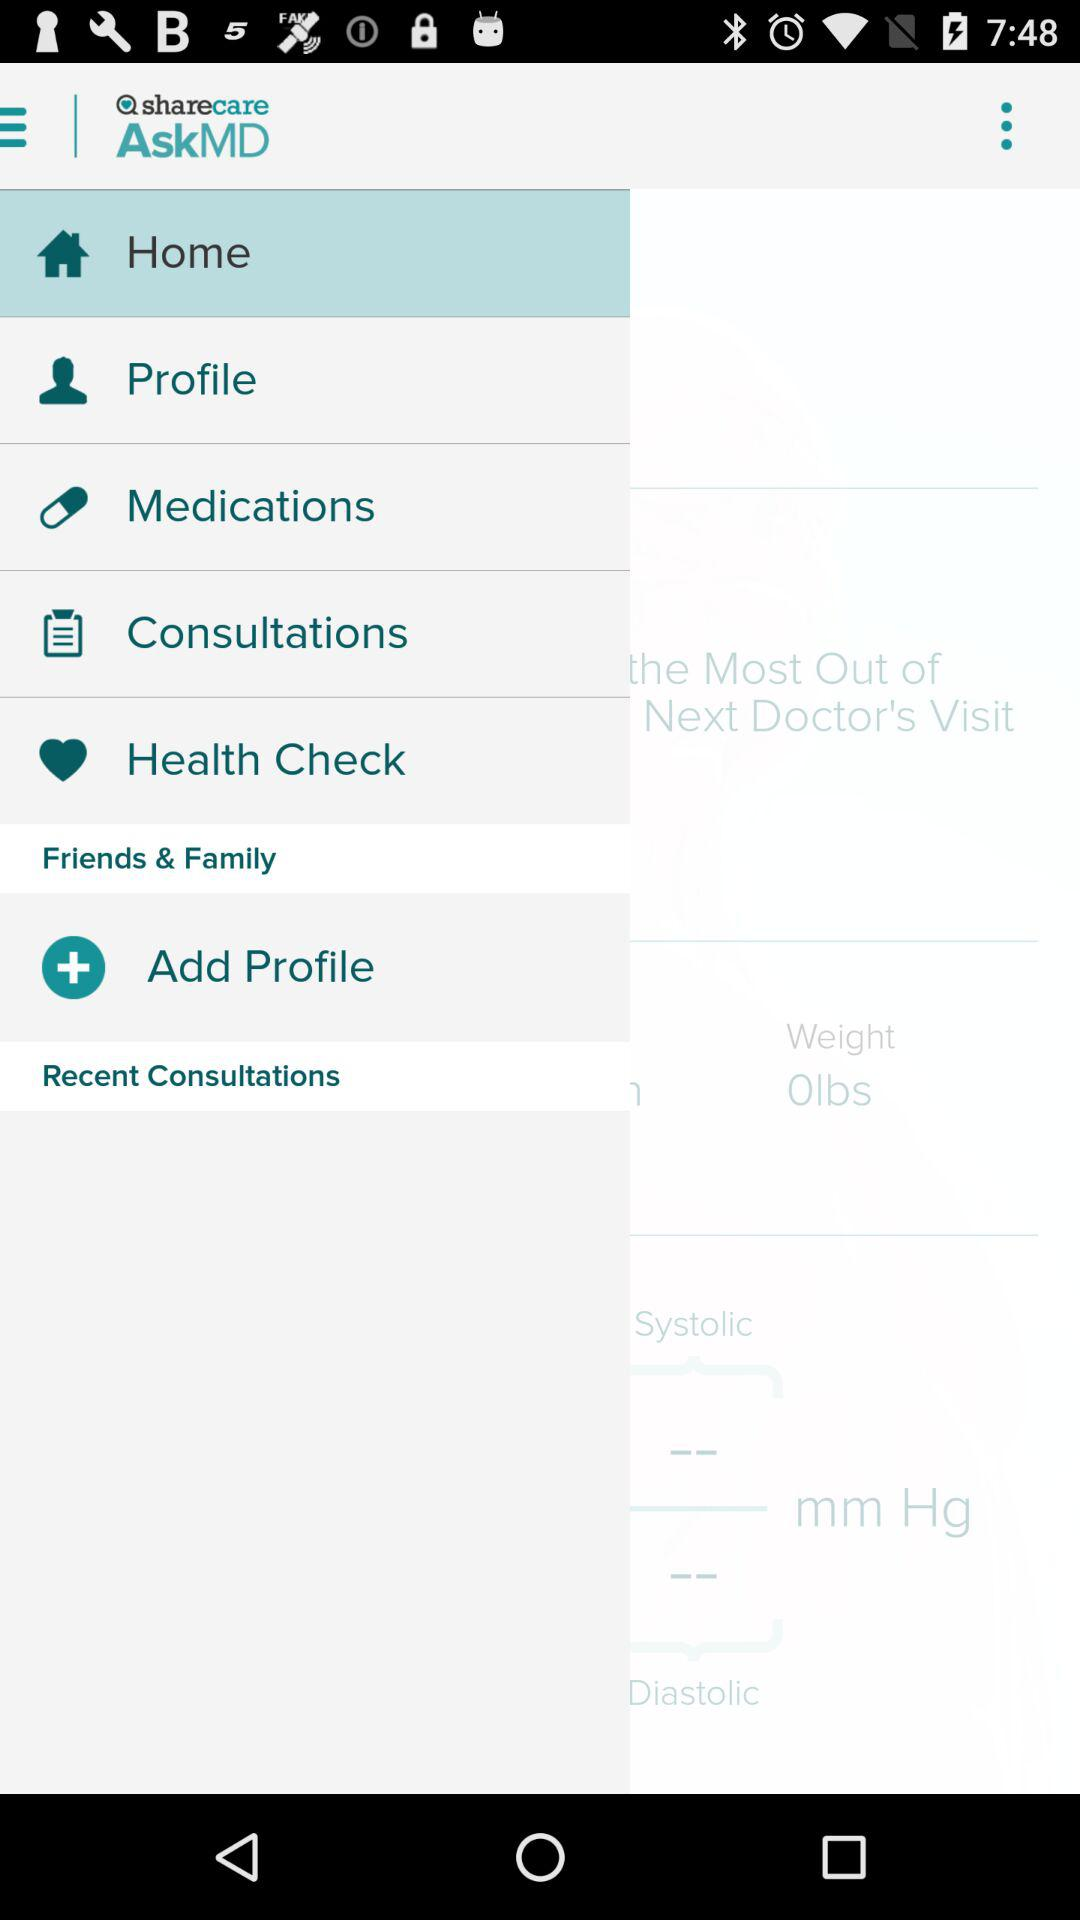Does the user have a primary care physician?
When the provided information is insufficient, respond with <no answer>. <no answer> 